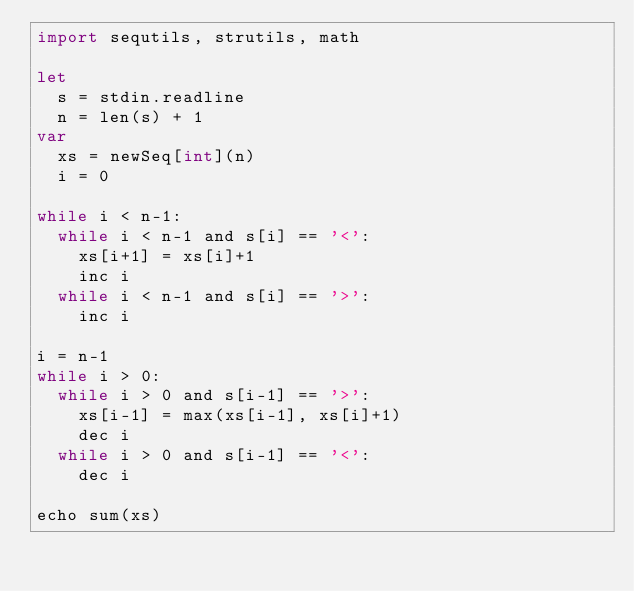Convert code to text. <code><loc_0><loc_0><loc_500><loc_500><_Nim_>import sequtils, strutils, math

let
  s = stdin.readline
  n = len(s) + 1
var
  xs = newSeq[int](n)
  i = 0

while i < n-1:
  while i < n-1 and s[i] == '<':
    xs[i+1] = xs[i]+1
    inc i
  while i < n-1 and s[i] == '>':
    inc i

i = n-1
while i > 0:
  while i > 0 and s[i-1] == '>':
    xs[i-1] = max(xs[i-1], xs[i]+1)
    dec i
  while i > 0 and s[i-1] == '<':
    dec i

echo sum(xs)
</code> 